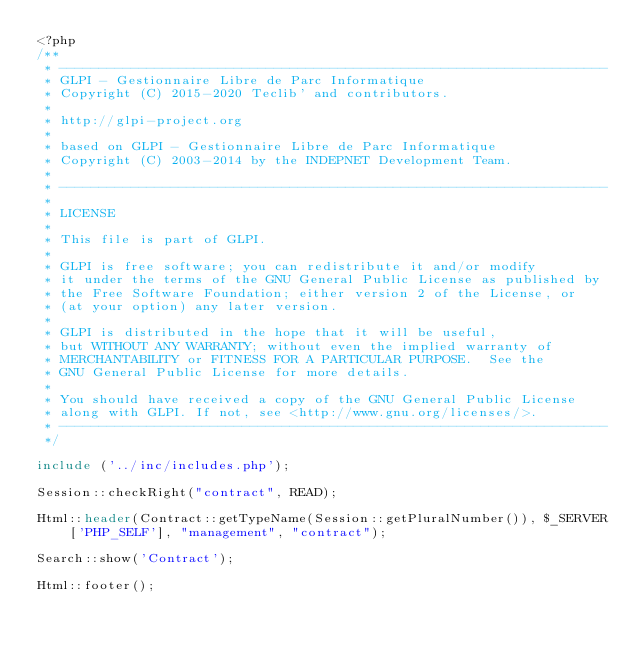Convert code to text. <code><loc_0><loc_0><loc_500><loc_500><_PHP_><?php
/**
 * ---------------------------------------------------------------------
 * GLPI - Gestionnaire Libre de Parc Informatique
 * Copyright (C) 2015-2020 Teclib' and contributors.
 *
 * http://glpi-project.org
 *
 * based on GLPI - Gestionnaire Libre de Parc Informatique
 * Copyright (C) 2003-2014 by the INDEPNET Development Team.
 *
 * ---------------------------------------------------------------------
 *
 * LICENSE
 *
 * This file is part of GLPI.
 *
 * GLPI is free software; you can redistribute it and/or modify
 * it under the terms of the GNU General Public License as published by
 * the Free Software Foundation; either version 2 of the License, or
 * (at your option) any later version.
 *
 * GLPI is distributed in the hope that it will be useful,
 * but WITHOUT ANY WARRANTY; without even the implied warranty of
 * MERCHANTABILITY or FITNESS FOR A PARTICULAR PURPOSE.  See the
 * GNU General Public License for more details.
 *
 * You should have received a copy of the GNU General Public License
 * along with GLPI. If not, see <http://www.gnu.org/licenses/>.
 * ---------------------------------------------------------------------
 */

include ('../inc/includes.php');

Session::checkRight("contract", READ);

Html::header(Contract::getTypeName(Session::getPluralNumber()), $_SERVER['PHP_SELF'], "management", "contract");

Search::show('Contract');

Html::footer();
</code> 